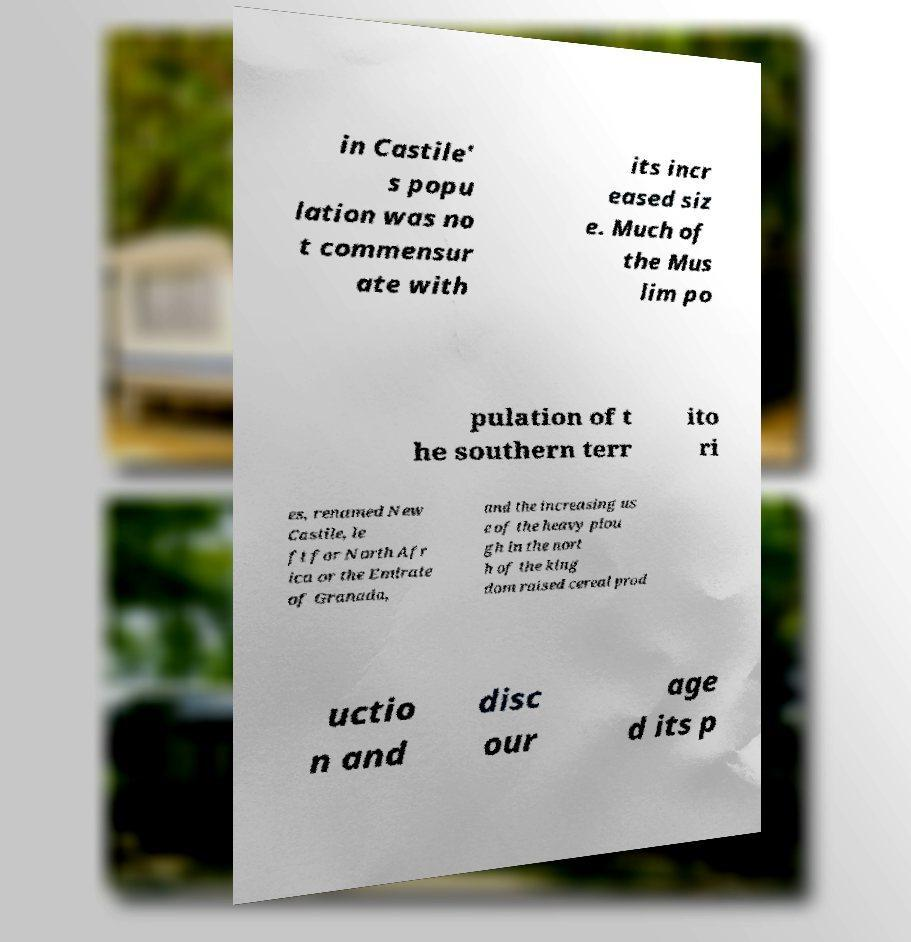Can you accurately transcribe the text from the provided image for me? in Castile' s popu lation was no t commensur ate with its incr eased siz e. Much of the Mus lim po pulation of t he southern terr ito ri es, renamed New Castile, le ft for North Afr ica or the Emirate of Granada, and the increasing us e of the heavy plou gh in the nort h of the king dom raised cereal prod uctio n and disc our age d its p 